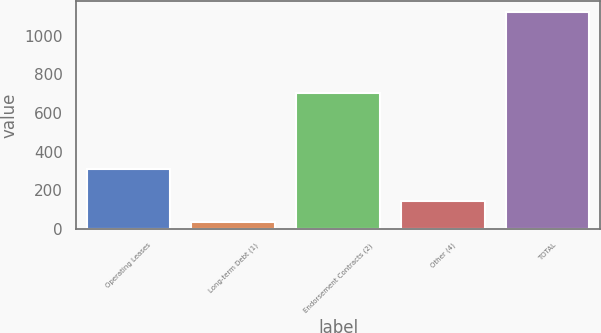Convert chart to OTSL. <chart><loc_0><loc_0><loc_500><loc_500><bar_chart><fcel>Operating Leases<fcel>Long-term Debt (1)<fcel>Endorsement Contracts (2)<fcel>Other (4)<fcel>TOTAL<nl><fcel>311<fcel>36<fcel>706<fcel>144.9<fcel>1125<nl></chart> 